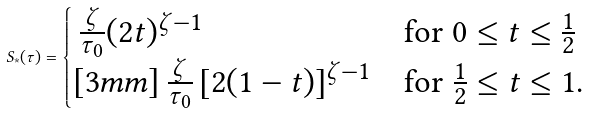<formula> <loc_0><loc_0><loc_500><loc_500>S _ { * } ( \tau ) = \begin{cases} \, \frac { \zeta } { \tau _ { 0 } } ( 2 t ) ^ { \zeta - 1 } & \text {for $0\leq t\leq\frac{1}{2}$} \\ [ 3 m m ] \, \frac { \zeta } { \tau _ { 0 } } \left [ 2 ( 1 - t ) \right ] ^ { \zeta - 1 } & \text {for $\frac{1}{2}\leq t \leq 1$.} \end{cases}</formula> 